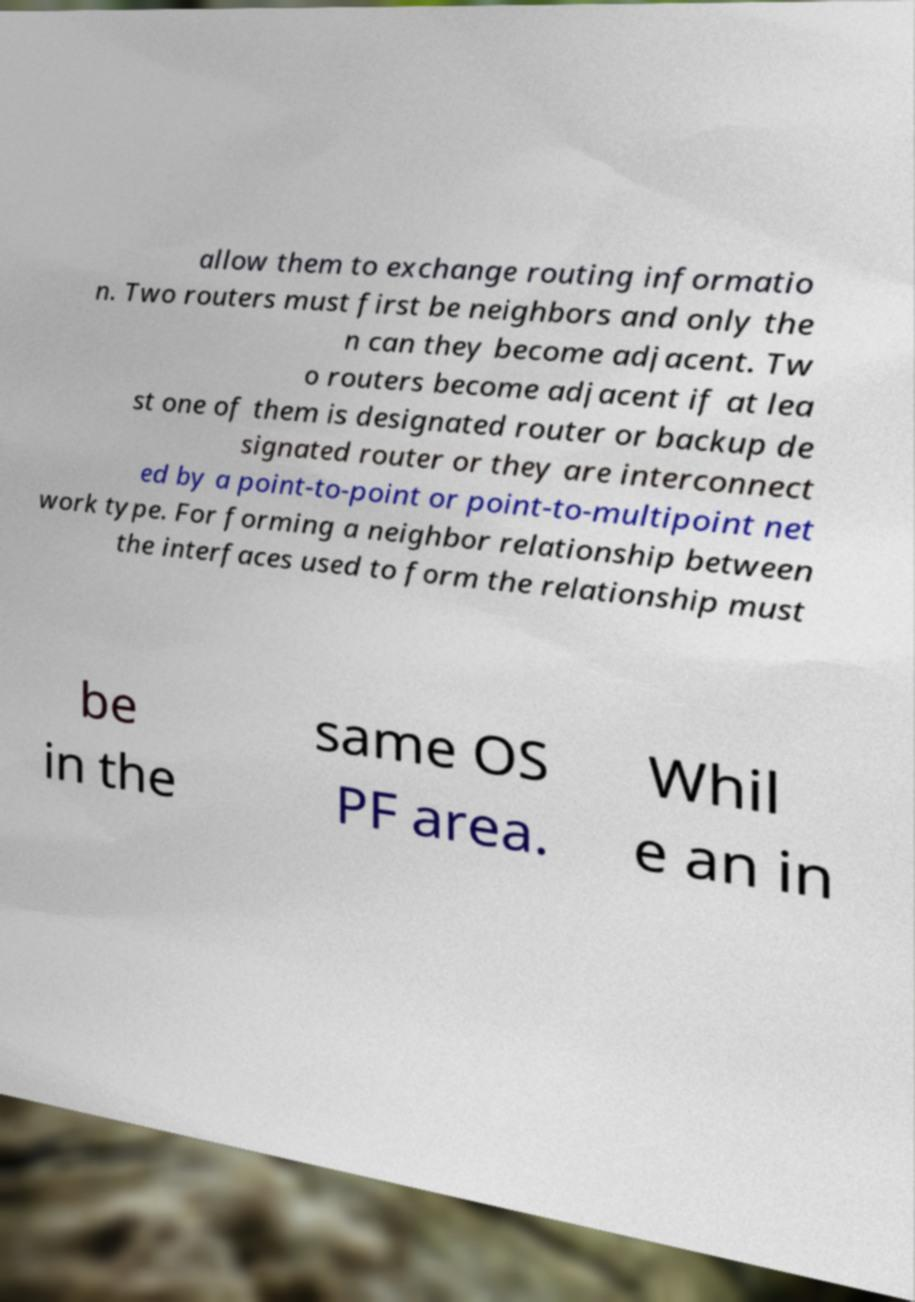Can you read and provide the text displayed in the image?This photo seems to have some interesting text. Can you extract and type it out for me? allow them to exchange routing informatio n. Two routers must first be neighbors and only the n can they become adjacent. Tw o routers become adjacent if at lea st one of them is designated router or backup de signated router or they are interconnect ed by a point-to-point or point-to-multipoint net work type. For forming a neighbor relationship between the interfaces used to form the relationship must be in the same OS PF area. Whil e an in 